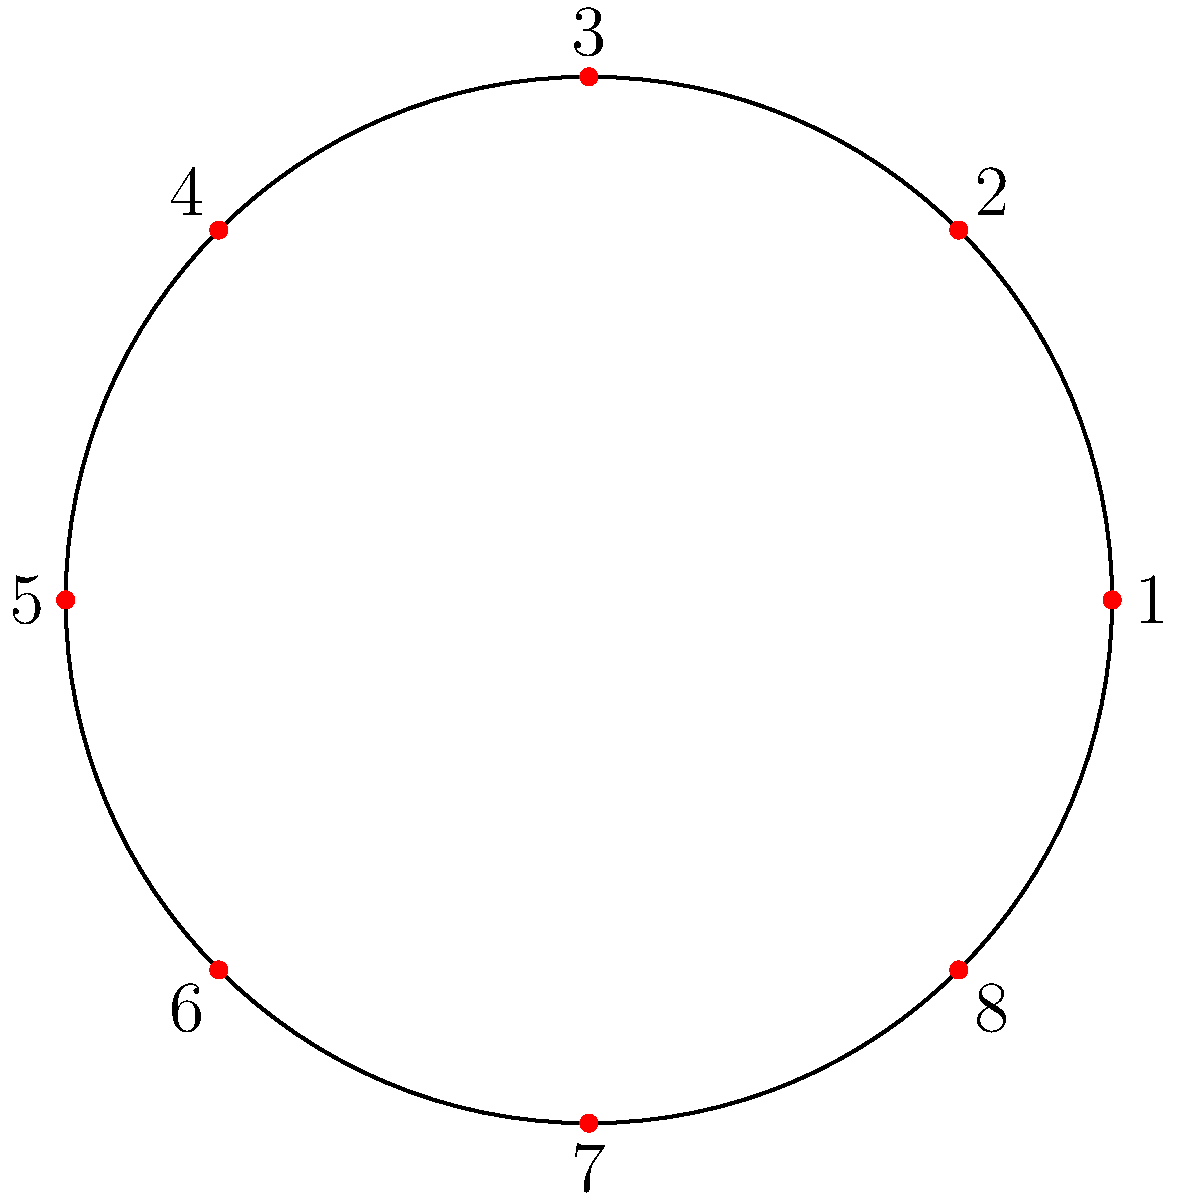In a trendy movie theater's circular VIP lounge, 8 seats are arranged as shown in the diagram. If a group of friends can sit in any rotated version of their seating arrangement, how many unique seating arrangements are possible for 8 people? Let's approach this step-by-step:

1) First, we need to understand what rotational symmetry means in this context. Any rotation of a given seating arrangement is considered the same arrangement.

2) In group theory, this is related to the concept of cyclic groups. The rotational symmetry group of an 8-seat circular arrangement is isomorphic to the cyclic group $C_8$.

3) To find the number of unique arrangements, we need to use the concept of orbits and the Orbit-Stabilizer theorem.

4) The total number of possible arrangements without considering rotations would be $8!$ (8 factorial).

5) However, each unique arrangement can be rotated 8 ways (including the original position), which are all considered the same in our problem.

6) Therefore, the number of unique arrangements is:

   $\frac{\text{Total arrangements}}{\text{Number of rotations}} = \frac{8!}{8} = 7!$

7) We can calculate this:
   $7! = 7 \times 6 \times 5 \times 4 \times 3 \times 2 \times 1 = 5040$

Thus, there are 5040 unique seating arrangements possible.
Answer: 5040 